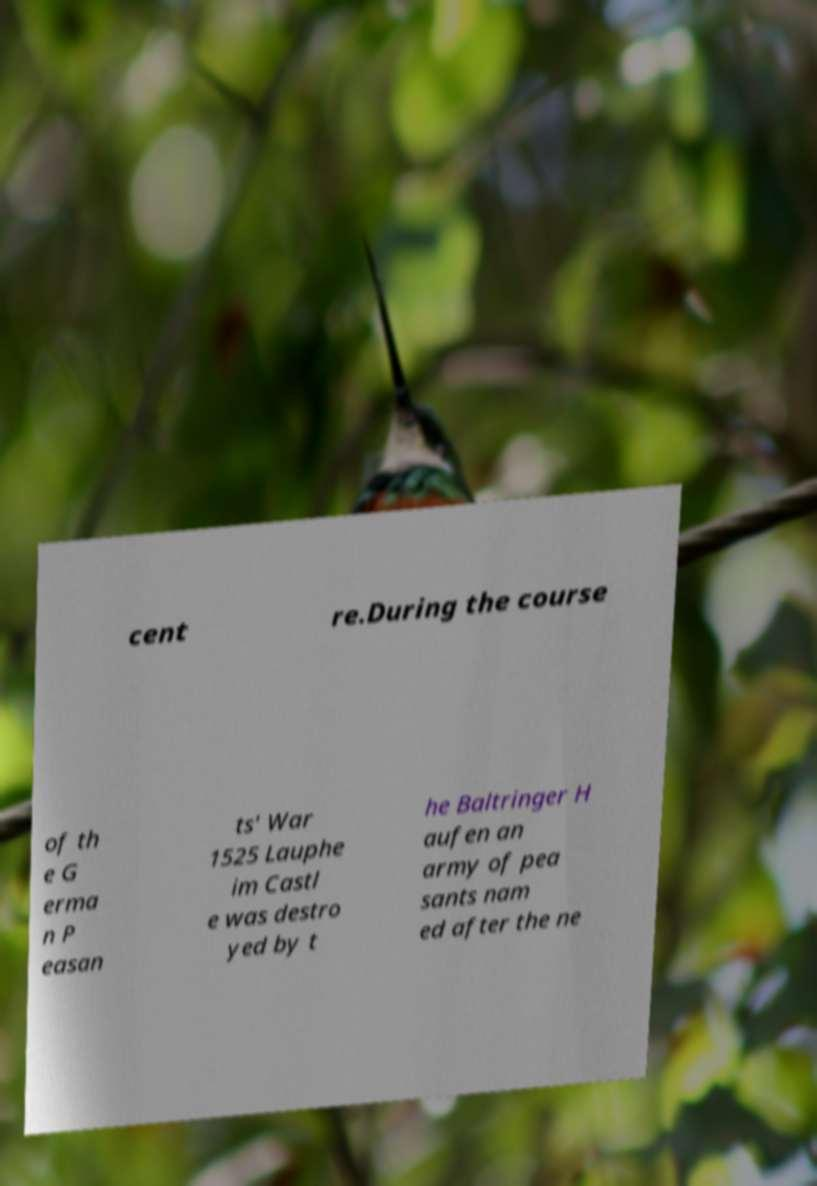Could you assist in decoding the text presented in this image and type it out clearly? cent re.During the course of th e G erma n P easan ts' War 1525 Lauphe im Castl e was destro yed by t he Baltringer H aufen an army of pea sants nam ed after the ne 